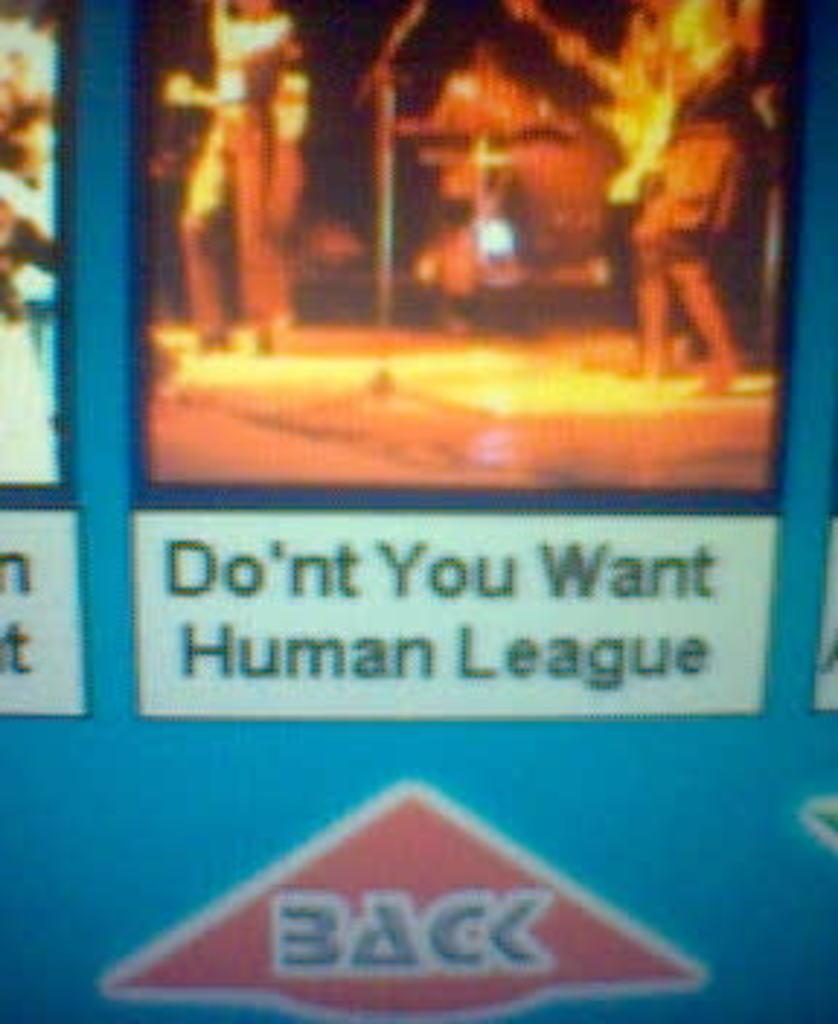What is the primary subject of the image or video displayed on the screen? The screen displays an image or video with humans in it. What type of eggnog is being served to the humans in the image or video? There is no eggnog present in the image or video, as it only features humans. What type of sheet is covering the humans in the image or video? There is no sheet covering the humans in the image or video, as it only features humans. 